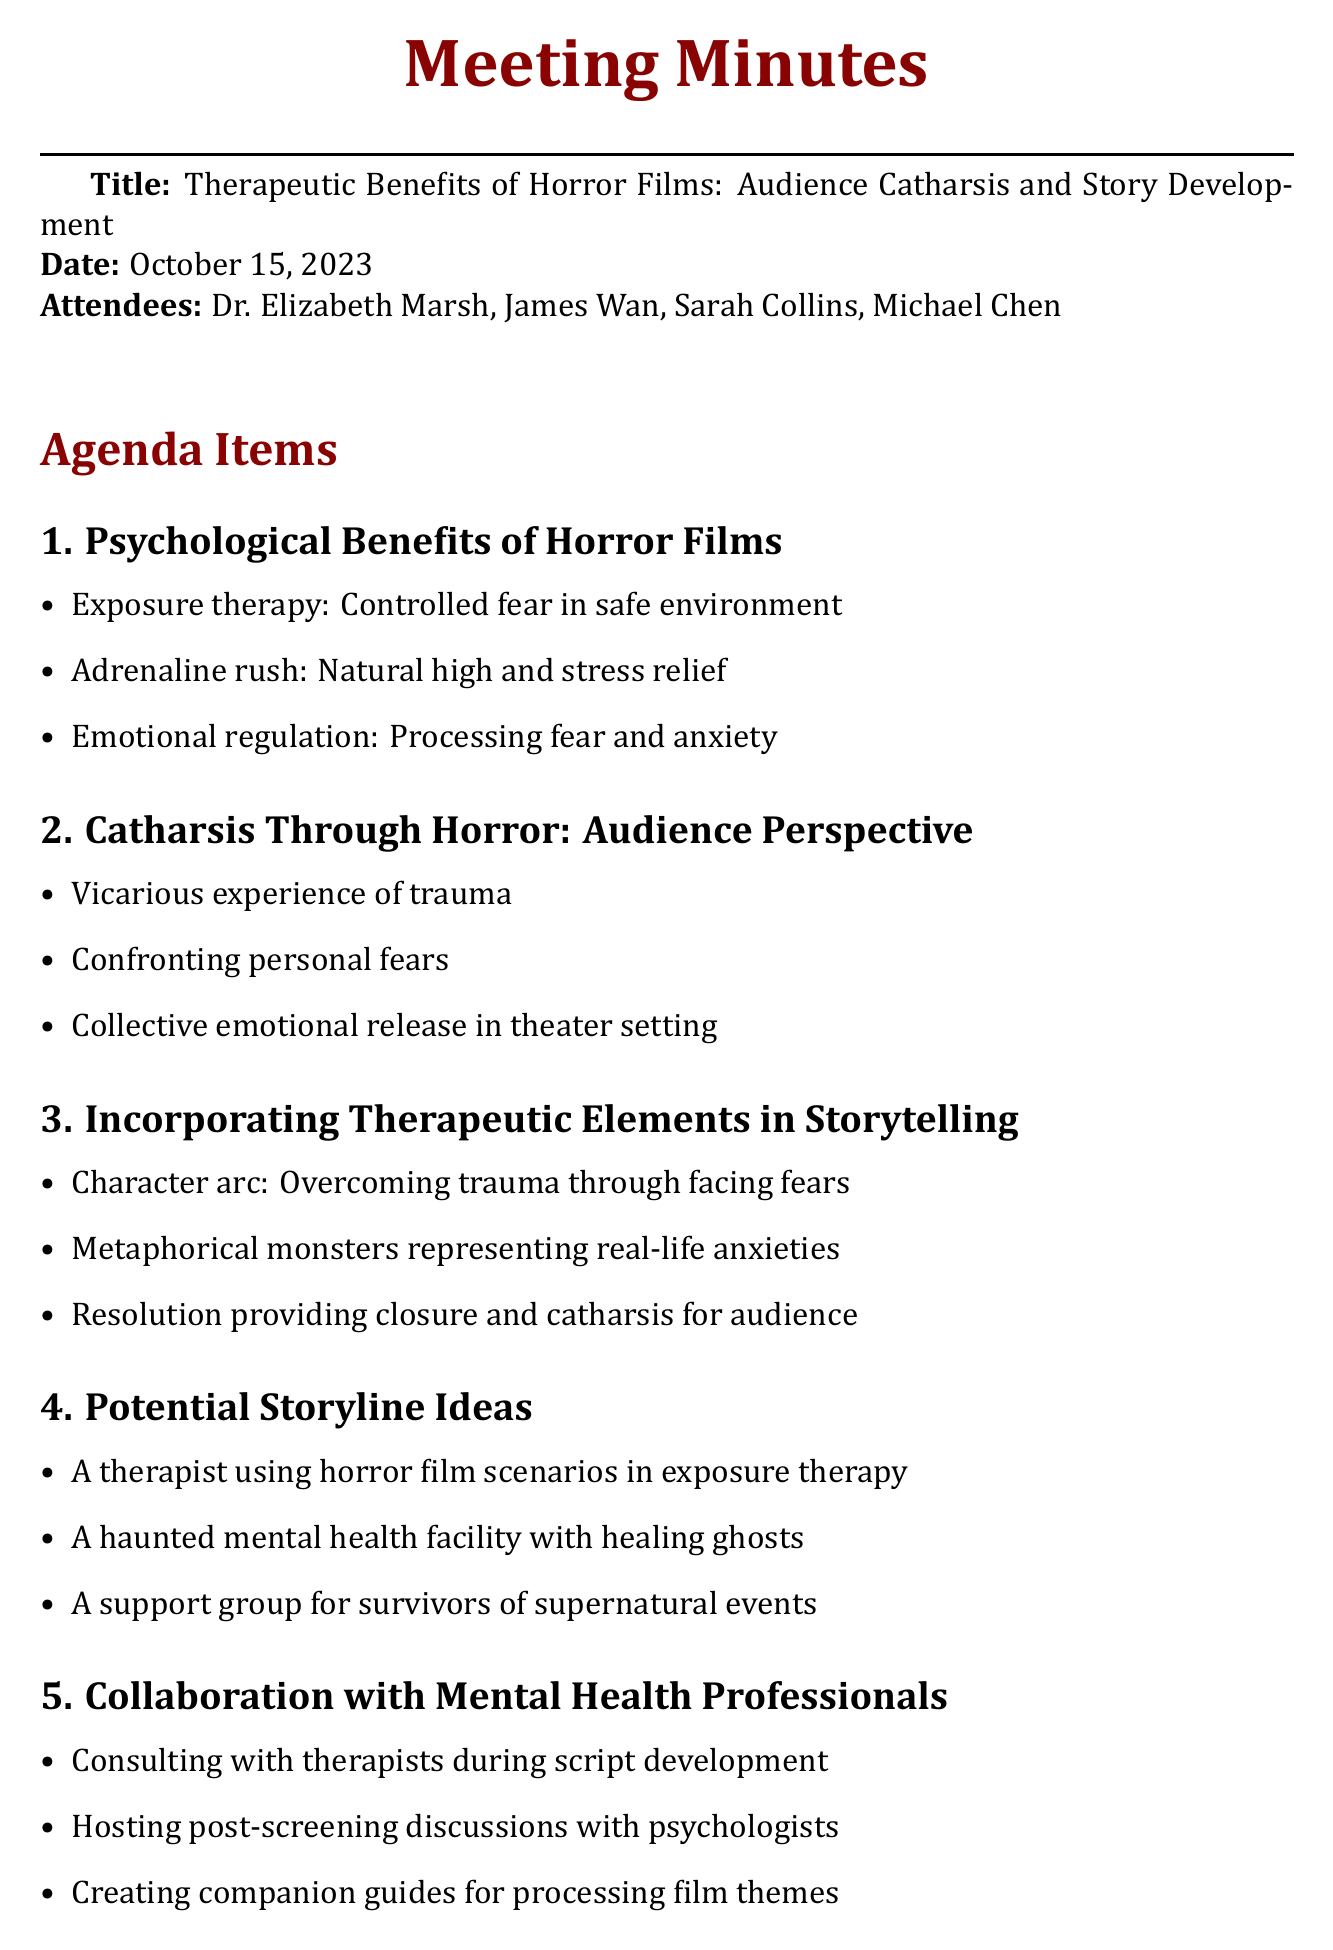What is the meeting title? The meeting title is located at the beginning of the document under "Title."
Answer: Therapeutic Benefits of Horror Films: Audience Catharsis and Story Development Who is the guest speaker? The guest speaker's name is mentioned in the list of attendees.
Answer: James Wan What date was the meeting held? The date can be found directly beneath the title in the document.
Answer: October 15, 2023 What is one psychological benefit of horror films discussed? This benefit is part of the agenda item on psychological benefits.
Answer: Exposure therapy: Controlled fear in safe environment What is a potential storyline idea mentioned? Potential storyline ideas are listed under the relevant agenda item.
Answer: A therapist using horror film scenarios in exposure therapy How many attendees were present at the meeting? The number of attendees can be counted from the list provided in the document.
Answer: Four What is one action item mentioned in the document? Action items are specifically listed at the end of the document.
Answer: Research successful horror films with strong therapeutic themes What therapeutic element involves characters facing fears? This element is discussed in the agenda item on incorporating therapeutic elements.
Answer: Character arc: Overcoming trauma through facing fears What kind of professionals does the document suggest collaborating with? This relates to a specific agenda item in the document.
Answer: Mental health professionals 